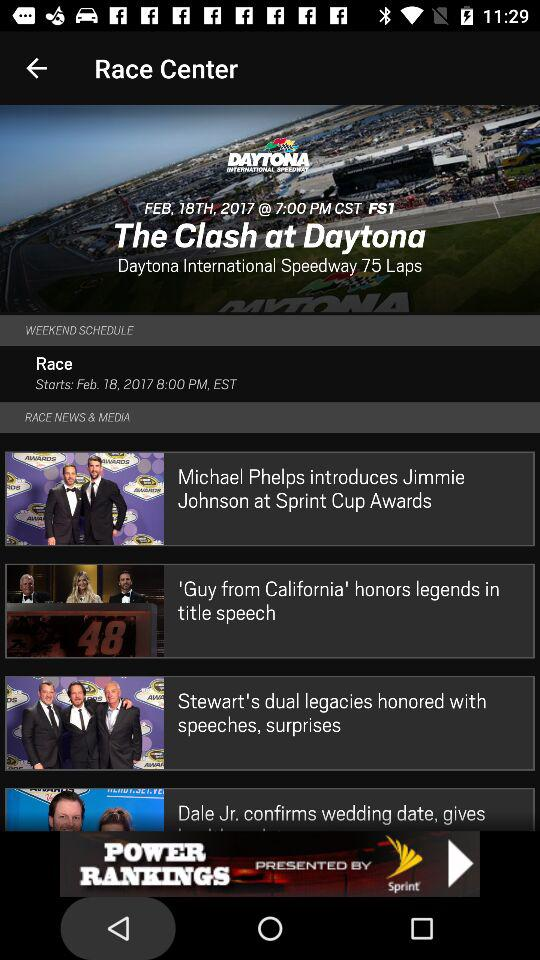How many sections are there in the NASCAR.COM privacy policy?
Answer the question using a single word or phrase. 3 